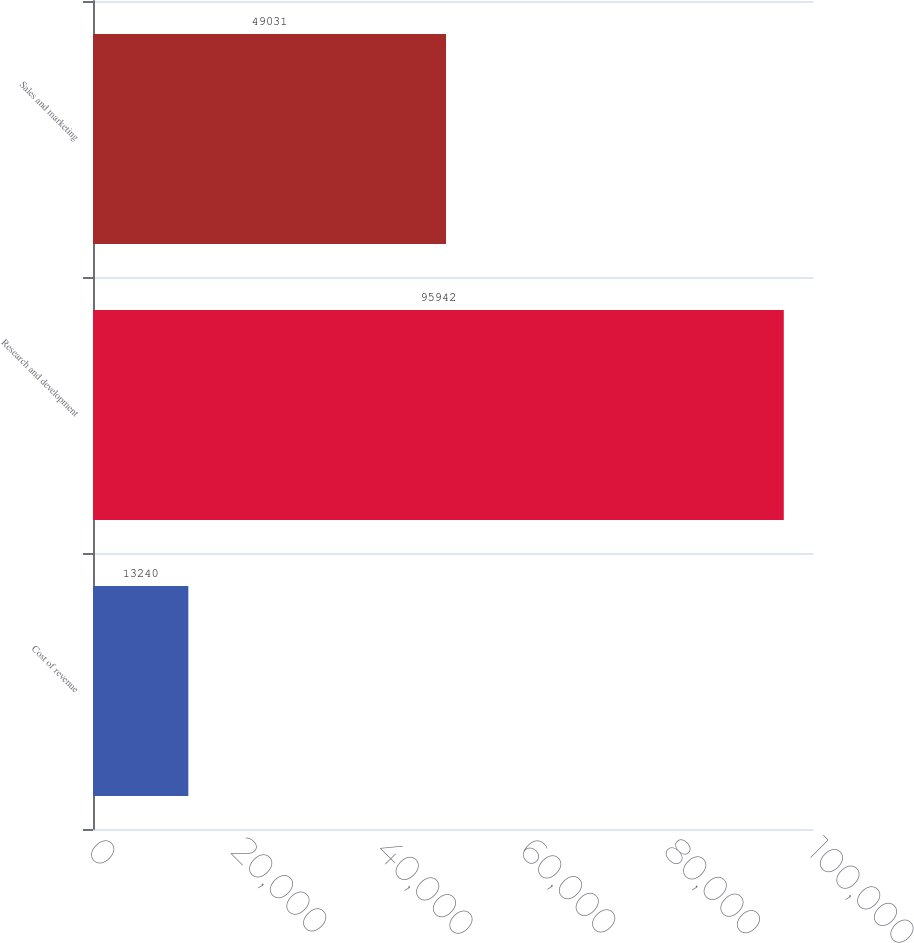<chart> <loc_0><loc_0><loc_500><loc_500><bar_chart><fcel>Cost of revenue<fcel>Research and development<fcel>Sales and marketing<nl><fcel>13240<fcel>95942<fcel>49031<nl></chart> 